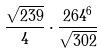<formula> <loc_0><loc_0><loc_500><loc_500>\frac { \sqrt { 2 3 9 } } { 4 } \cdot \frac { 2 6 4 ^ { 6 } } { \sqrt { 3 0 2 } }</formula> 